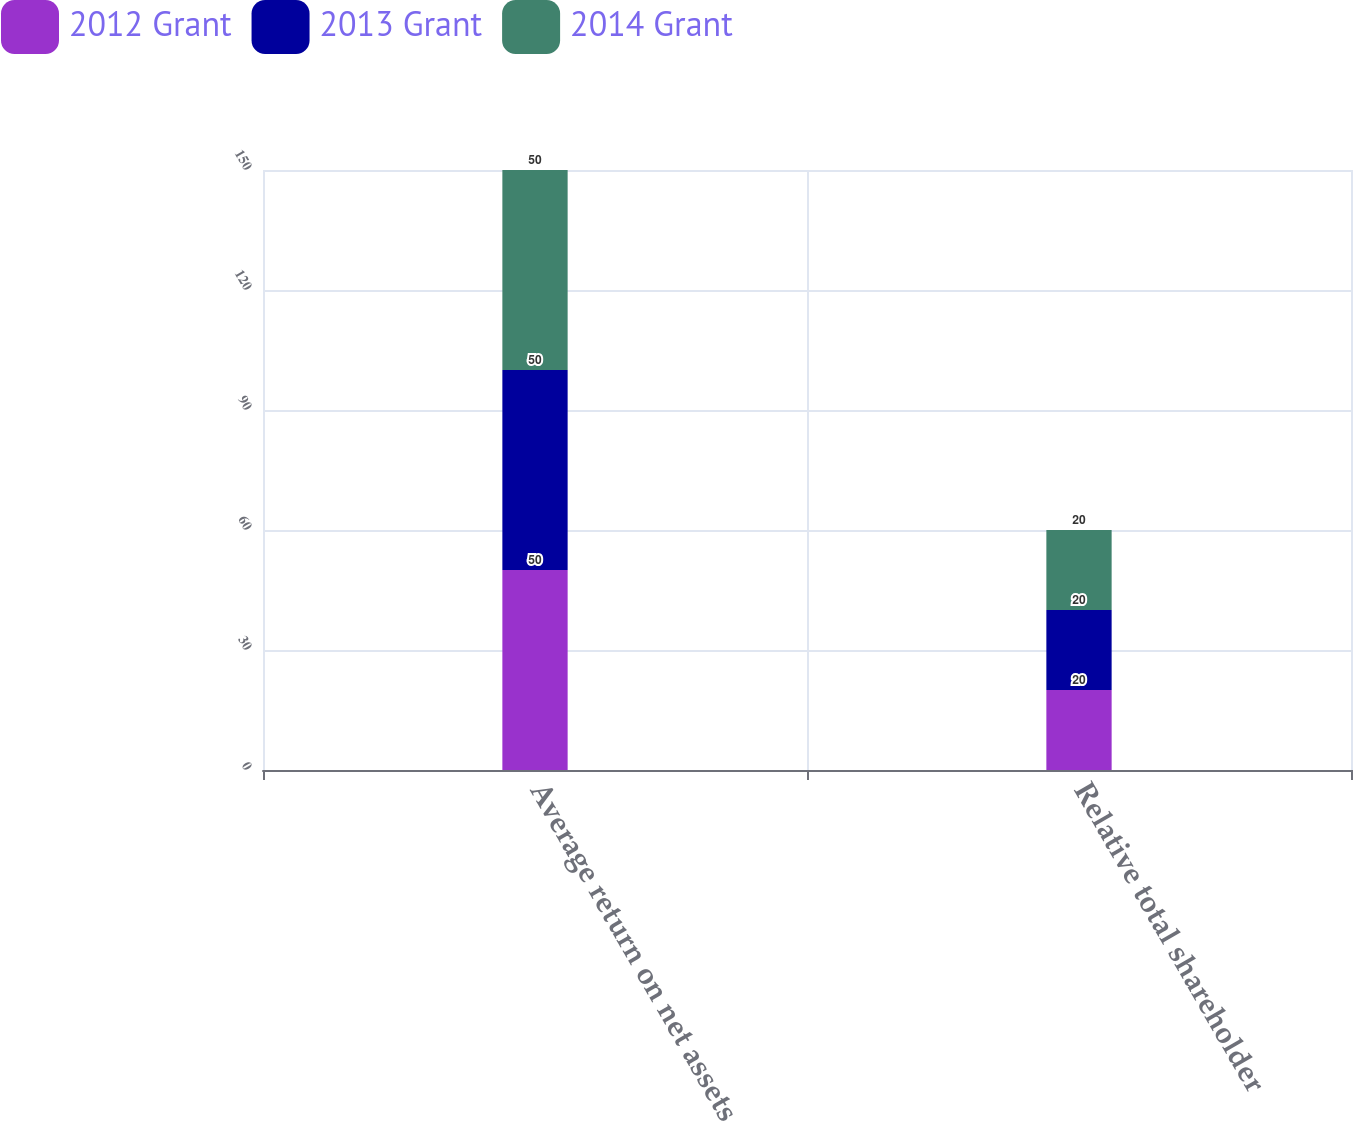Convert chart to OTSL. <chart><loc_0><loc_0><loc_500><loc_500><stacked_bar_chart><ecel><fcel>Average return on net assets<fcel>Relative total shareholder<nl><fcel>2012 Grant<fcel>50<fcel>20<nl><fcel>2013 Grant<fcel>50<fcel>20<nl><fcel>2014 Grant<fcel>50<fcel>20<nl></chart> 